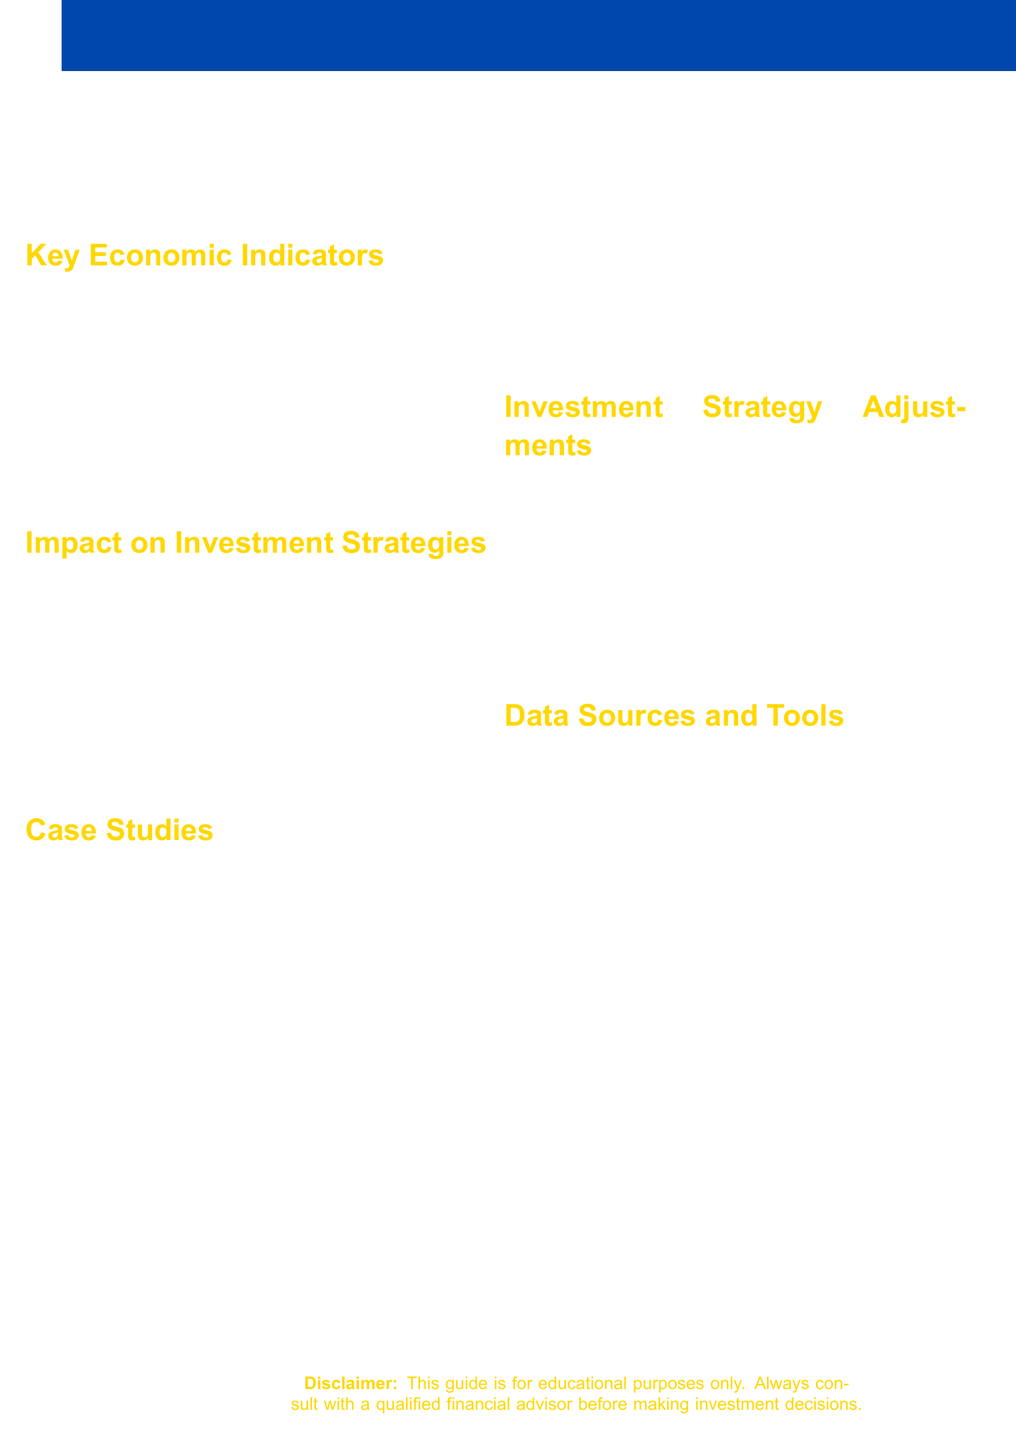what are the key economic indicators listed? The document lists five key economic indicators, which are GDP, CPI, Unemployment Rate, PMI, and Interest Rates.
Answer: GDP, CPI, Unemployment Rate, PMI, Interest Rates how many case studies are included? The document provides three case studies related to major economic events.
Answer: 3 which data source is mentioned first? The document lists data sources in order, and the first one mentioned is Bloomberg Terminal.
Answer: Bloomberg Terminal name one impact on investment strategies. The impacts on investment strategies listed in the document include Equity Market Fluctuations.
Answer: Equity Market Fluctuations what adjustment strategy involves market volatility? Hedging strategies in volatile markets is mentioned as an adjustment strategy.
Answer: Hedging strategies in volatile markets which economic event is associated with the year 2020? The document refers to the COVID-19 Pandemic as the global economic event for that year.
Answer: COVID-19 Pandemic which color is used for the text headings in the document? The text headings in the document are colored banker gold.
Answer: banker gold how many items are listed under investment strategy adjustments? The document lists four distinct items under investment strategy adjustments.
Answer: 4 